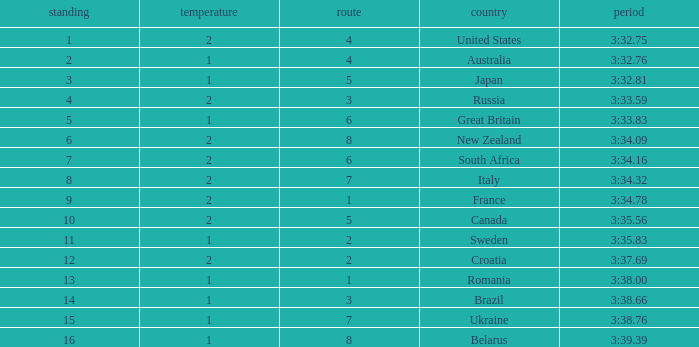Can you tell me the Time that has the Heat of 1, and the Lane of 2? 3:35.83. 